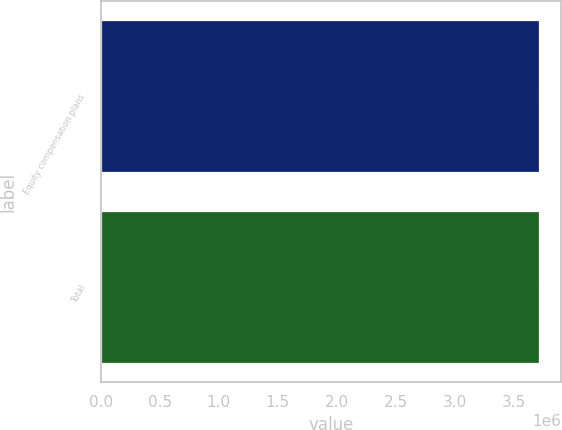<chart> <loc_0><loc_0><loc_500><loc_500><bar_chart><fcel>Equity compensation plans<fcel>Total<nl><fcel>3.7174e+06<fcel>3.71741e+06<nl></chart> 